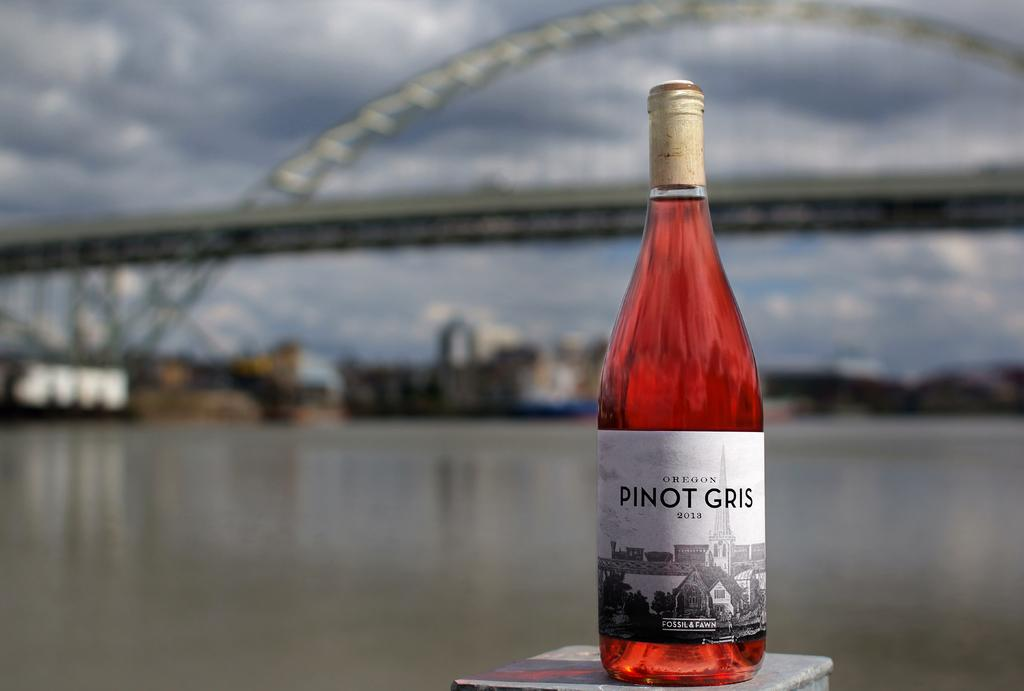What color is the bottle that is visible in the image? There is a red bottle in the image. What can be seen in the background of the image? Water, a bridge, and the sky are visible in the background of the image. How is the sky depicted in the image? The sky is visible in the background of the image, but it is blurred. What type of sheet is draped over the bridge in the image? There is no sheet present in the image; it only features a red bottle, water, a bridge, and a blurred sky in the background. 